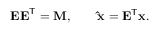Convert formula to latex. <formula><loc_0><loc_0><loc_500><loc_500>E E ^ { T } = M , \quad \hat { x } = E ^ { T } x .</formula> 